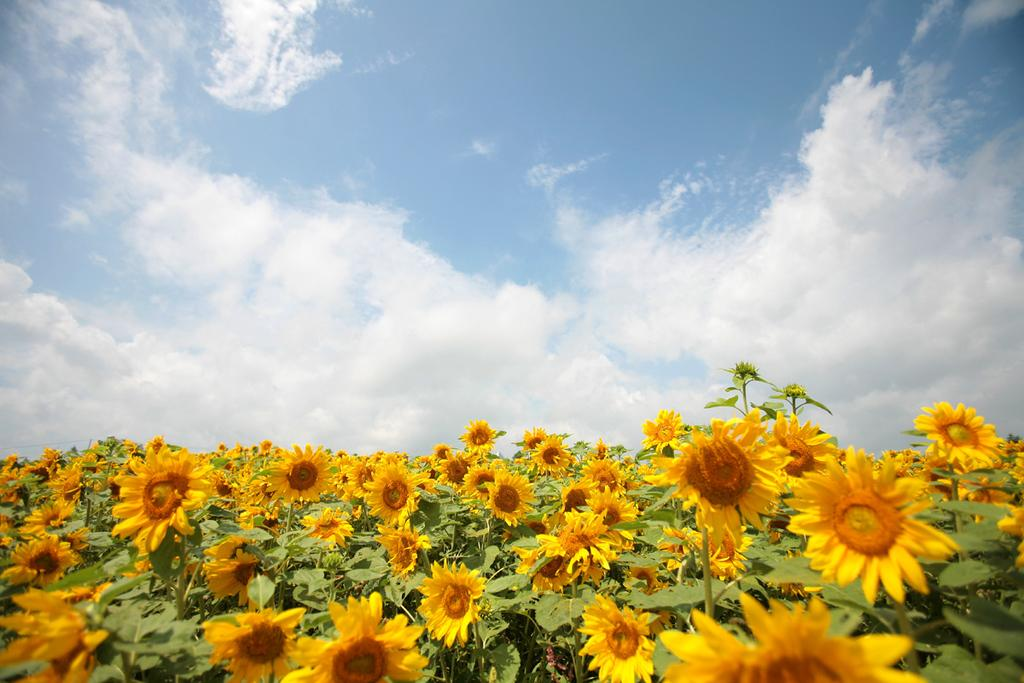What type of flowers are in the image? There are sunflowers in the image. What other types of plants are in the image? There are plants in the image. What can be seen in the background of the image? There is a sky visible in the background of the image. What is visible in the sky in the image? There are clouds in the sky. What is the cause of the sunflowers growing in the image? There is no information provided about the cause of the sunflowers growing in the image. What role does the mother play in the image? There is no mention of a mother or any human presence in the image. 